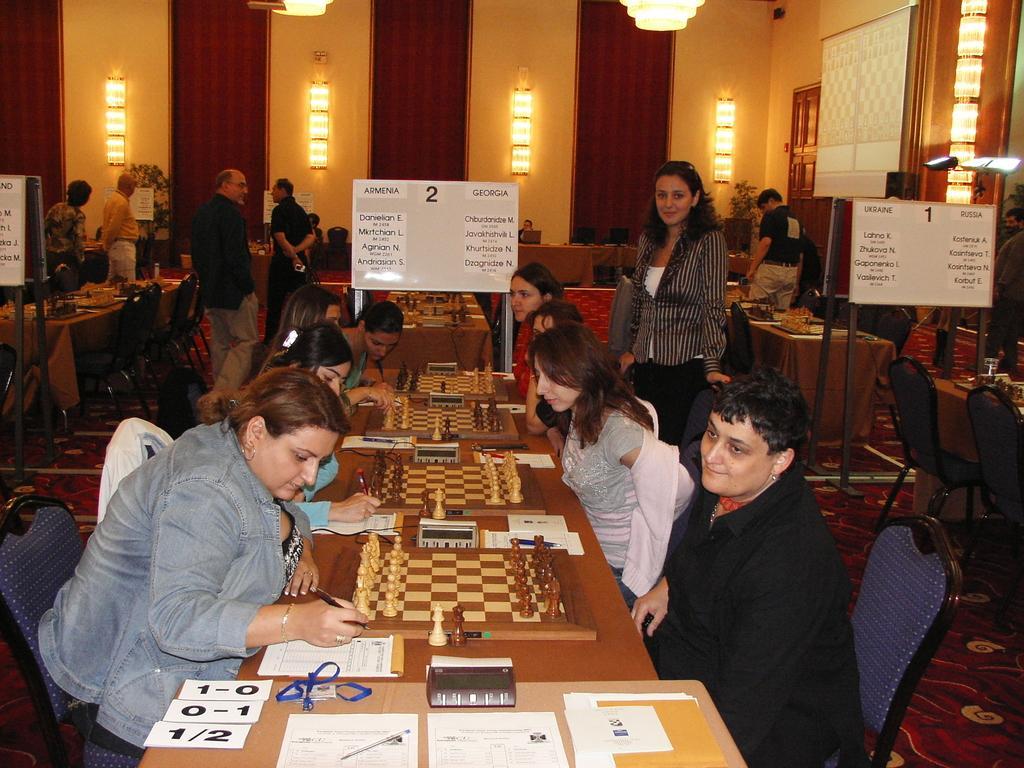Can you describe this image briefly? There is a room with lot of chairs benches and and there are chess boards and crowd playing chess. There is a notice board showing the score of the game. 